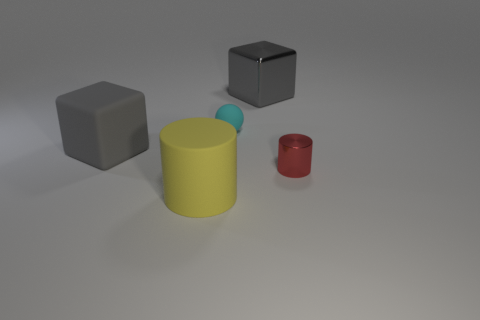Add 3 large brown spheres. How many objects exist? 8 Subtract all cylinders. How many objects are left? 3 Subtract all matte things. Subtract all big blocks. How many objects are left? 0 Add 5 gray matte cubes. How many gray matte cubes are left? 6 Add 3 yellow rubber cylinders. How many yellow rubber cylinders exist? 4 Subtract 0 brown spheres. How many objects are left? 5 